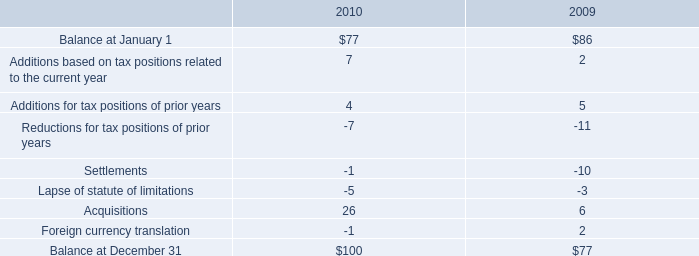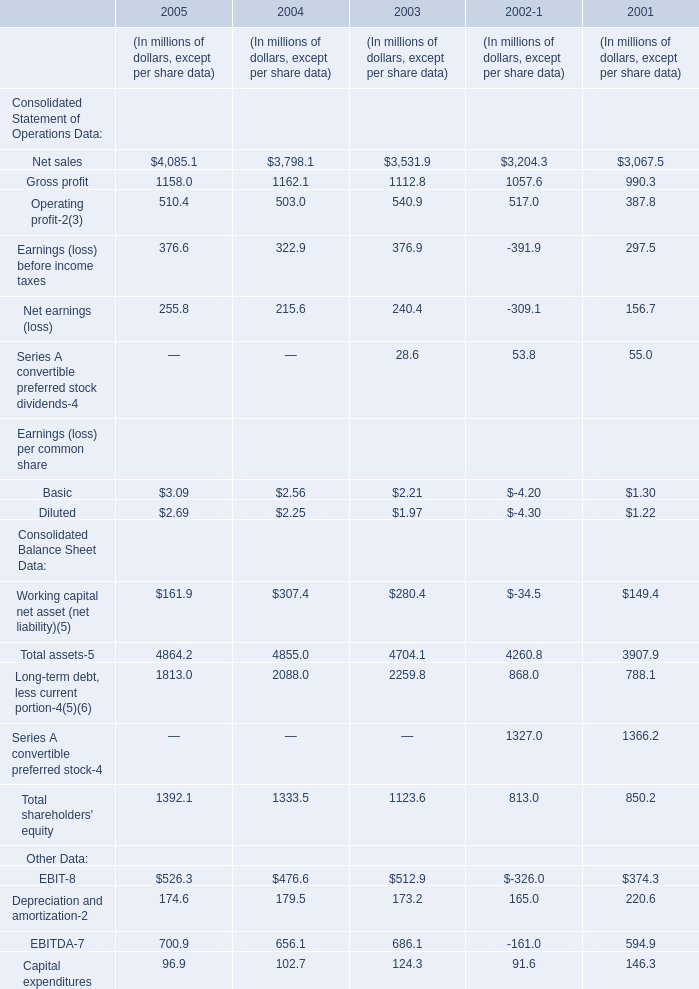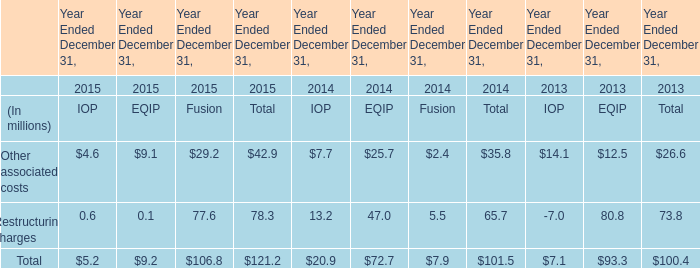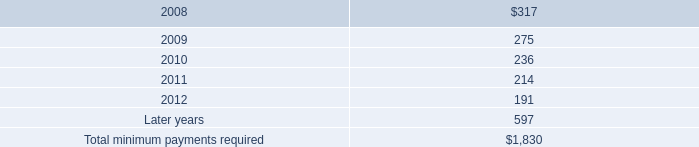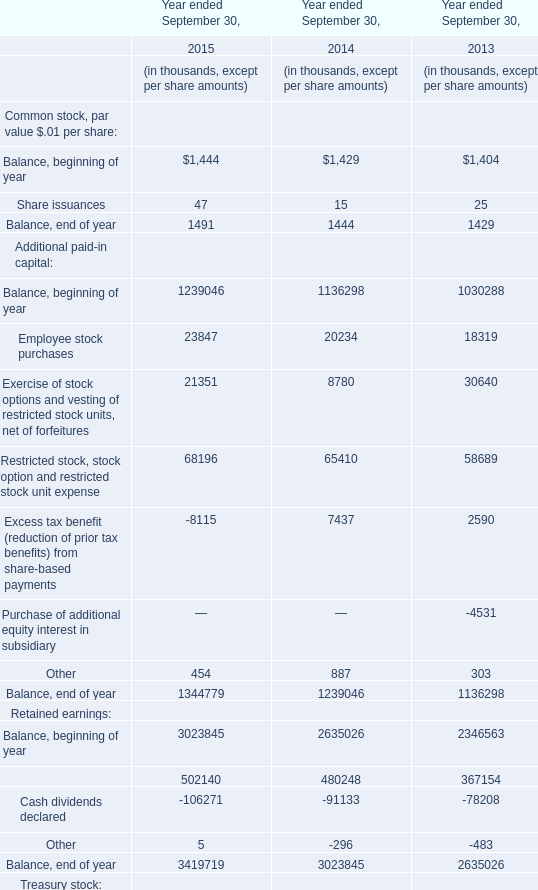In the year with the most gross profit, what is the growth rate of Net earnings (loss)? (in %) 
Computations: ((215.6 - 240.4) / 240.4)
Answer: -0.10316. 